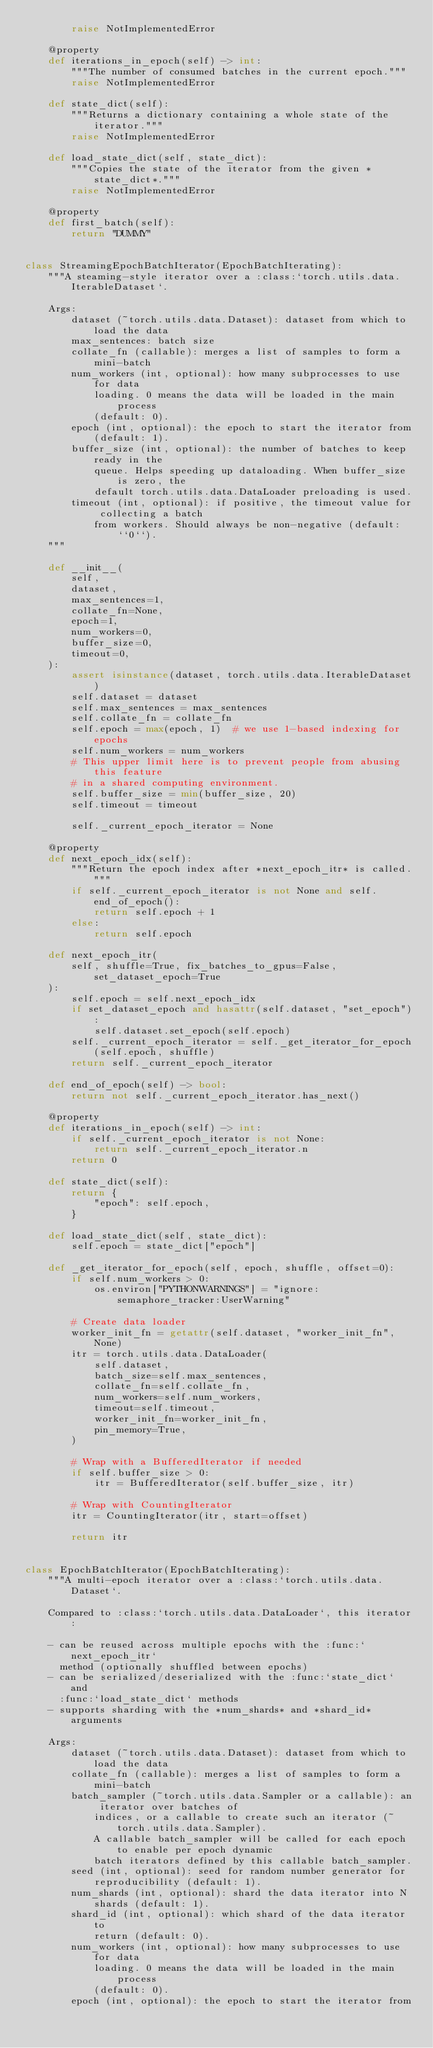<code> <loc_0><loc_0><loc_500><loc_500><_Python_>        raise NotImplementedError

    @property
    def iterations_in_epoch(self) -> int:
        """The number of consumed batches in the current epoch."""
        raise NotImplementedError

    def state_dict(self):
        """Returns a dictionary containing a whole state of the iterator."""
        raise NotImplementedError

    def load_state_dict(self, state_dict):
        """Copies the state of the iterator from the given *state_dict*."""
        raise NotImplementedError

    @property
    def first_batch(self):
        return "DUMMY"


class StreamingEpochBatchIterator(EpochBatchIterating):
    """A steaming-style iterator over a :class:`torch.utils.data.IterableDataset`.

    Args:
        dataset (~torch.utils.data.Dataset): dataset from which to load the data
        max_sentences: batch size
        collate_fn (callable): merges a list of samples to form a mini-batch
        num_workers (int, optional): how many subprocesses to use for data
            loading. 0 means the data will be loaded in the main process
            (default: 0).
        epoch (int, optional): the epoch to start the iterator from
            (default: 1).
        buffer_size (int, optional): the number of batches to keep ready in the
            queue. Helps speeding up dataloading. When buffer_size is zero, the
            default torch.utils.data.DataLoader preloading is used.
        timeout (int, optional): if positive, the timeout value for collecting a batch
            from workers. Should always be non-negative (default: ``0``).
    """

    def __init__(
        self,
        dataset,
        max_sentences=1,
        collate_fn=None,
        epoch=1,
        num_workers=0,
        buffer_size=0,
        timeout=0,
    ):
        assert isinstance(dataset, torch.utils.data.IterableDataset)
        self.dataset = dataset
        self.max_sentences = max_sentences
        self.collate_fn = collate_fn
        self.epoch = max(epoch, 1)  # we use 1-based indexing for epochs
        self.num_workers = num_workers
        # This upper limit here is to prevent people from abusing this feature
        # in a shared computing environment.
        self.buffer_size = min(buffer_size, 20)
        self.timeout = timeout

        self._current_epoch_iterator = None

    @property
    def next_epoch_idx(self):
        """Return the epoch index after *next_epoch_itr* is called."""
        if self._current_epoch_iterator is not None and self.end_of_epoch():
            return self.epoch + 1
        else:
            return self.epoch

    def next_epoch_itr(
        self, shuffle=True, fix_batches_to_gpus=False, set_dataset_epoch=True
    ):
        self.epoch = self.next_epoch_idx
        if set_dataset_epoch and hasattr(self.dataset, "set_epoch"):
            self.dataset.set_epoch(self.epoch)
        self._current_epoch_iterator = self._get_iterator_for_epoch(self.epoch, shuffle)
        return self._current_epoch_iterator

    def end_of_epoch(self) -> bool:
        return not self._current_epoch_iterator.has_next()

    @property
    def iterations_in_epoch(self) -> int:
        if self._current_epoch_iterator is not None:
            return self._current_epoch_iterator.n
        return 0

    def state_dict(self):
        return {
            "epoch": self.epoch,
        }

    def load_state_dict(self, state_dict):
        self.epoch = state_dict["epoch"]

    def _get_iterator_for_epoch(self, epoch, shuffle, offset=0):
        if self.num_workers > 0:
            os.environ["PYTHONWARNINGS"] = "ignore:semaphore_tracker:UserWarning"

        # Create data loader
        worker_init_fn = getattr(self.dataset, "worker_init_fn", None)
        itr = torch.utils.data.DataLoader(
            self.dataset,
            batch_size=self.max_sentences,
            collate_fn=self.collate_fn,
            num_workers=self.num_workers,
            timeout=self.timeout,
            worker_init_fn=worker_init_fn,
            pin_memory=True,
        )

        # Wrap with a BufferedIterator if needed
        if self.buffer_size > 0:
            itr = BufferedIterator(self.buffer_size, itr)

        # Wrap with CountingIterator
        itr = CountingIterator(itr, start=offset)

        return itr


class EpochBatchIterator(EpochBatchIterating):
    """A multi-epoch iterator over a :class:`torch.utils.data.Dataset`.

    Compared to :class:`torch.utils.data.DataLoader`, this iterator:

    - can be reused across multiple epochs with the :func:`next_epoch_itr`
      method (optionally shuffled between epochs)
    - can be serialized/deserialized with the :func:`state_dict` and
      :func:`load_state_dict` methods
    - supports sharding with the *num_shards* and *shard_id* arguments

    Args:
        dataset (~torch.utils.data.Dataset): dataset from which to load the data
        collate_fn (callable): merges a list of samples to form a mini-batch
        batch_sampler (~torch.utils.data.Sampler or a callable): an iterator over batches of
            indices, or a callable to create such an iterator (~torch.utils.data.Sampler).
            A callable batch_sampler will be called for each epoch to enable per epoch dynamic
            batch iterators defined by this callable batch_sampler.
        seed (int, optional): seed for random number generator for
            reproducibility (default: 1).
        num_shards (int, optional): shard the data iterator into N
            shards (default: 1).
        shard_id (int, optional): which shard of the data iterator to
            return (default: 0).
        num_workers (int, optional): how many subprocesses to use for data
            loading. 0 means the data will be loaded in the main process
            (default: 0).
        epoch (int, optional): the epoch to start the iterator from</code> 